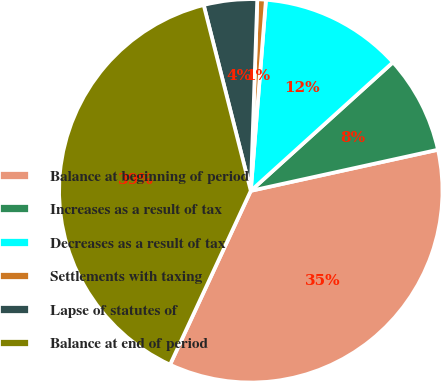Convert chart to OTSL. <chart><loc_0><loc_0><loc_500><loc_500><pie_chart><fcel>Balance at beginning of period<fcel>Increases as a result of tax<fcel>Decreases as a result of tax<fcel>Settlements with taxing<fcel>Lapse of statutes of<fcel>Balance at end of period<nl><fcel>35.36%<fcel>8.26%<fcel>12.04%<fcel>0.72%<fcel>4.49%<fcel>39.13%<nl></chart> 